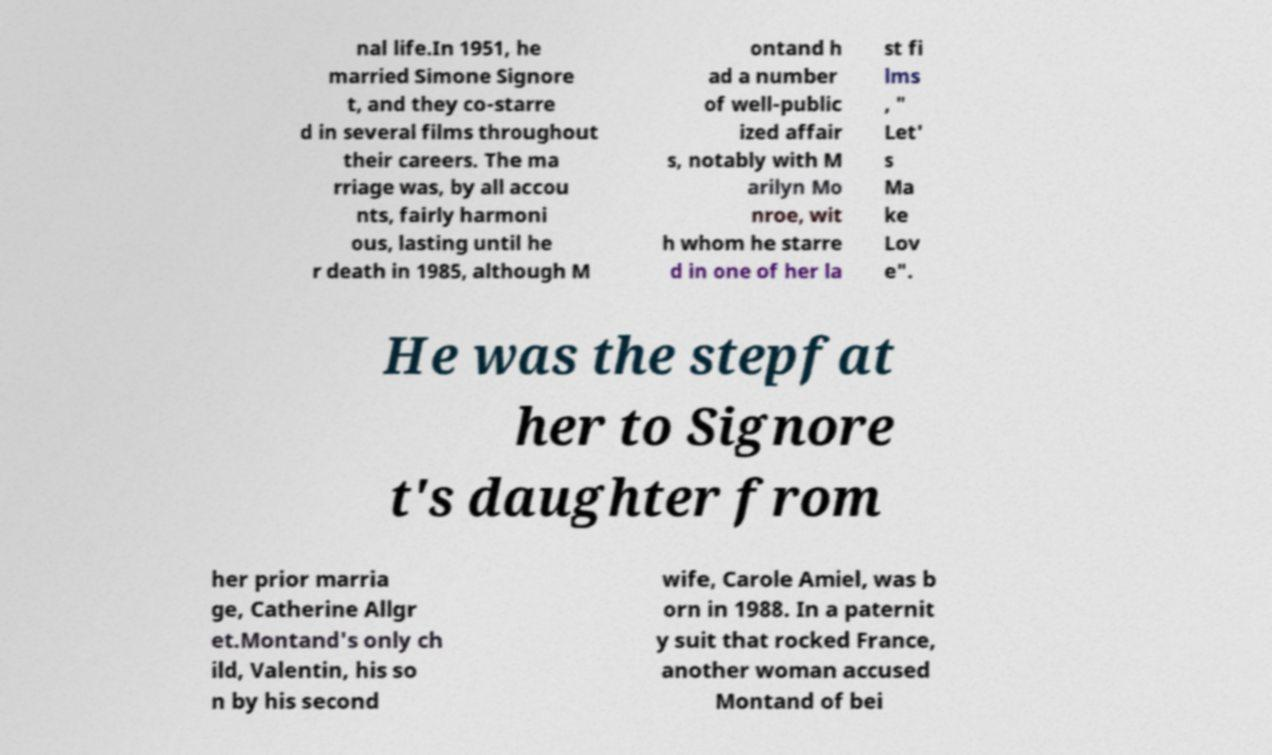Please read and relay the text visible in this image. What does it say? nal life.In 1951, he married Simone Signore t, and they co-starre d in several films throughout their careers. The ma rriage was, by all accou nts, fairly harmoni ous, lasting until he r death in 1985, although M ontand h ad a number of well-public ized affair s, notably with M arilyn Mo nroe, wit h whom he starre d in one of her la st fi lms , " Let' s Ma ke Lov e". He was the stepfat her to Signore t's daughter from her prior marria ge, Catherine Allgr et.Montand's only ch ild, Valentin, his so n by his second wife, Carole Amiel, was b orn in 1988. In a paternit y suit that rocked France, another woman accused Montand of bei 